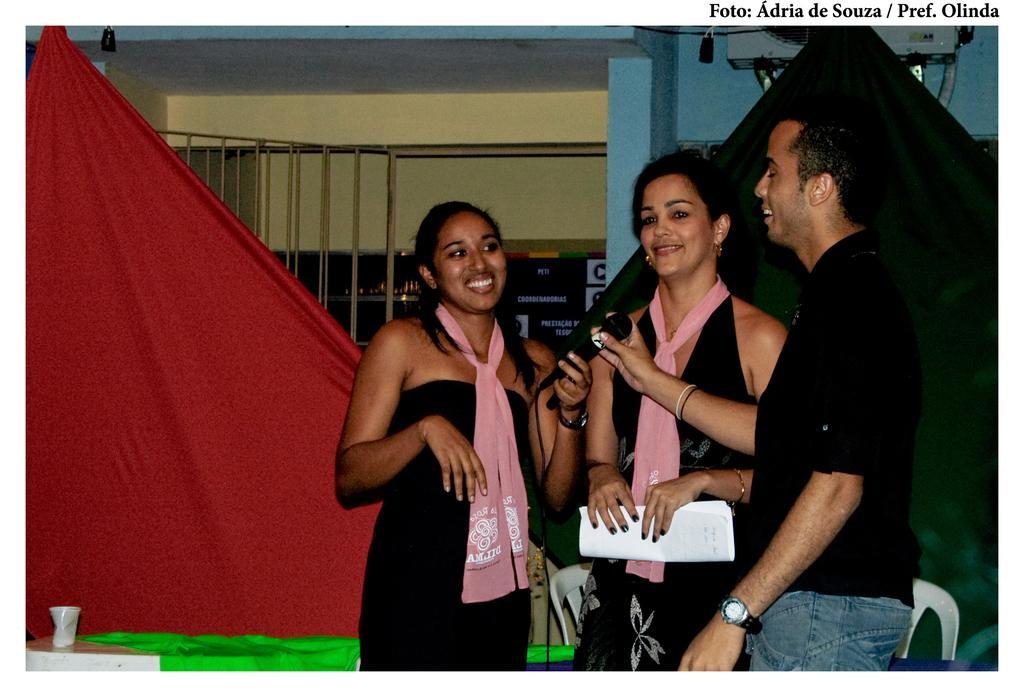Could you give a brief overview of what you see in this image? In this image I can see a man and two women are standing. I can see all of them are wearing black dress and I can see two of them are holding a mic. I can see she is holding a paper and I can see smile on their faces. In the background I can see red and black colour clothes, a glass, a green colour cloth and few chairs. 